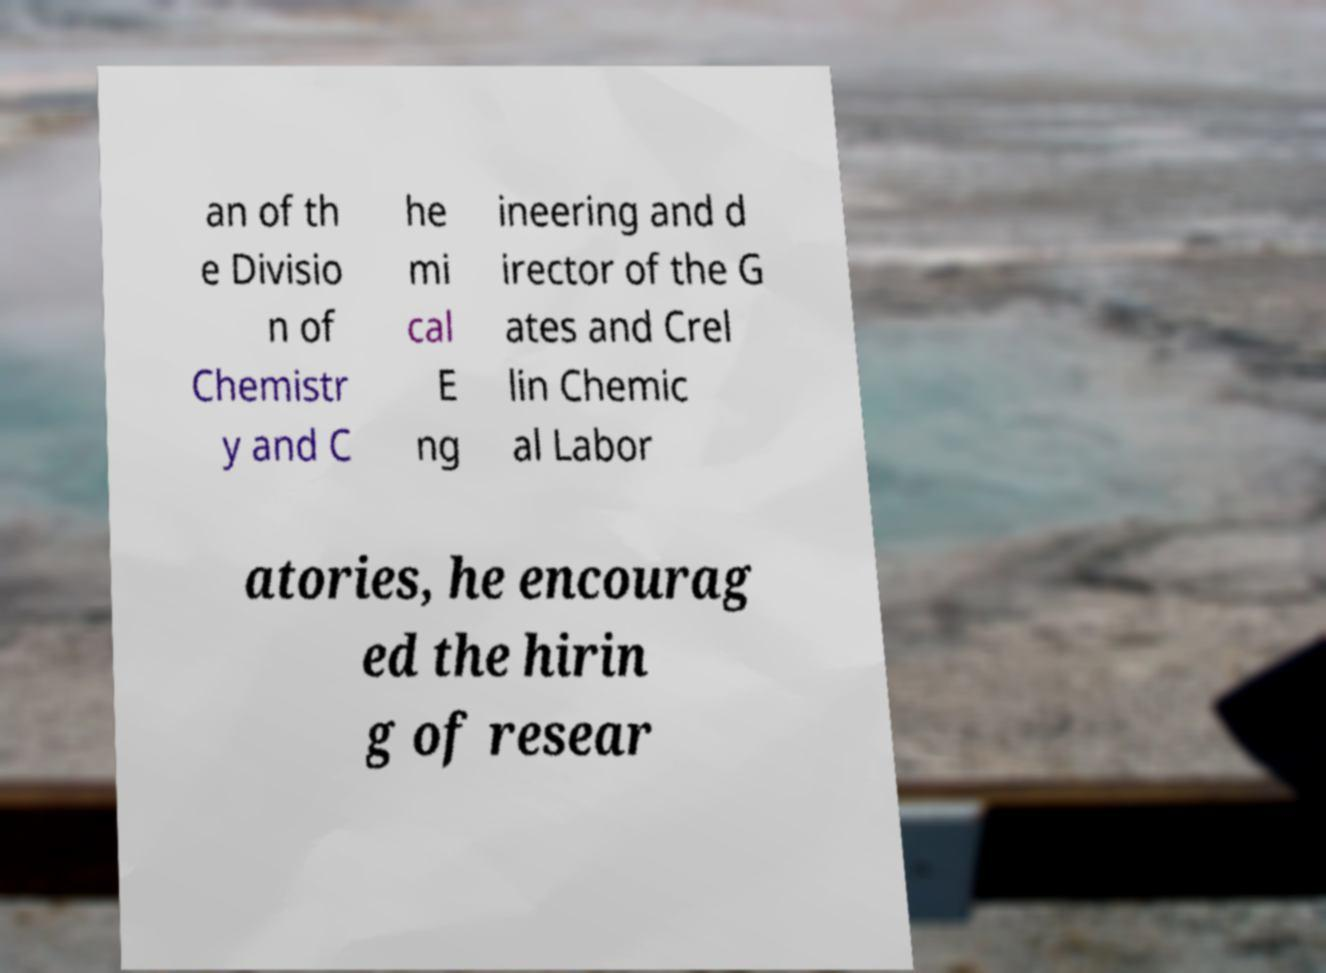For documentation purposes, I need the text within this image transcribed. Could you provide that? an of th e Divisio n of Chemistr y and C he mi cal E ng ineering and d irector of the G ates and Crel lin Chemic al Labor atories, he encourag ed the hirin g of resear 